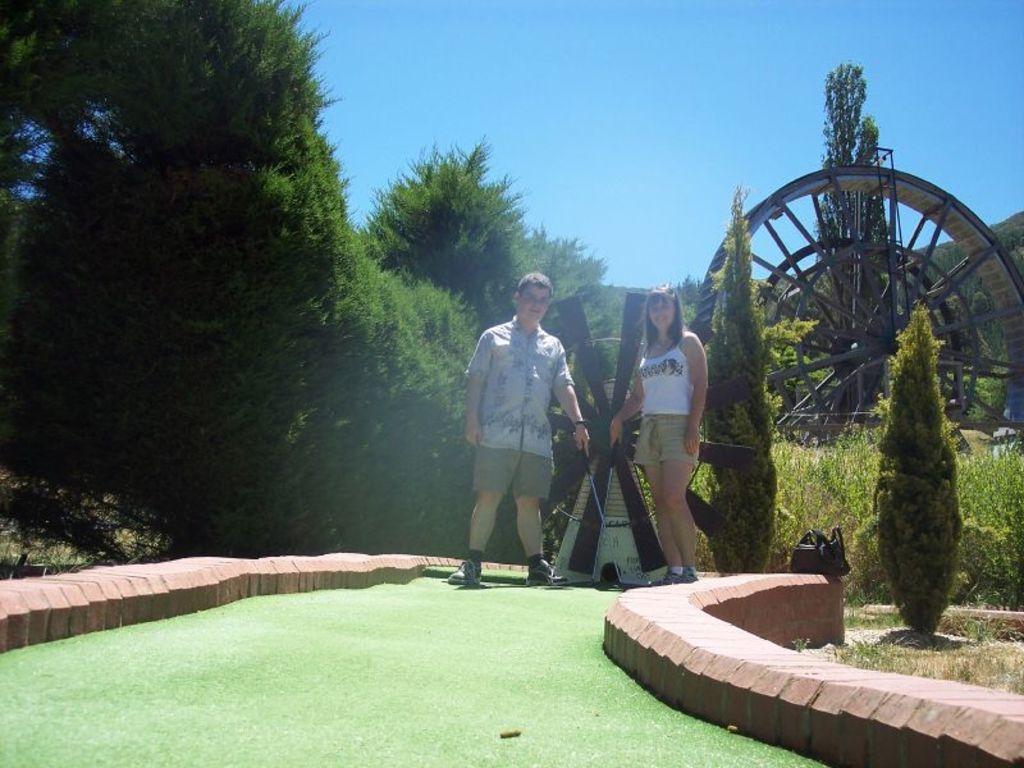Please provide a concise description of this image. In this picture there are two persons standing and holding the object. At the back there is a wheel and there are trees. At the bottom there is grass and there is a bag on the wall. At the top there is sky. 